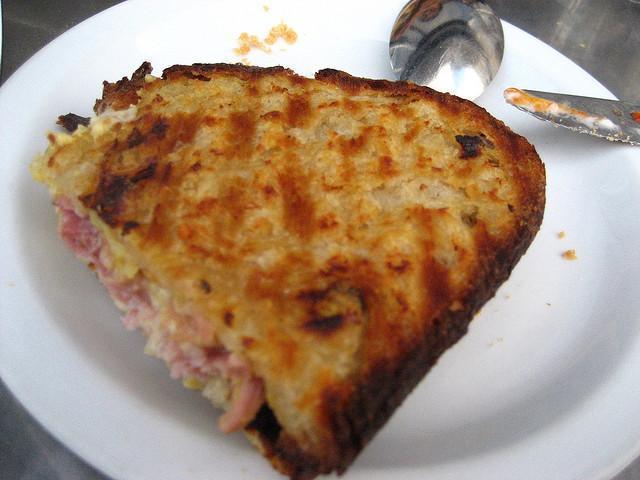How many knives can be seen?
Give a very brief answer. 1. How many standing cats are there?
Give a very brief answer. 0. 